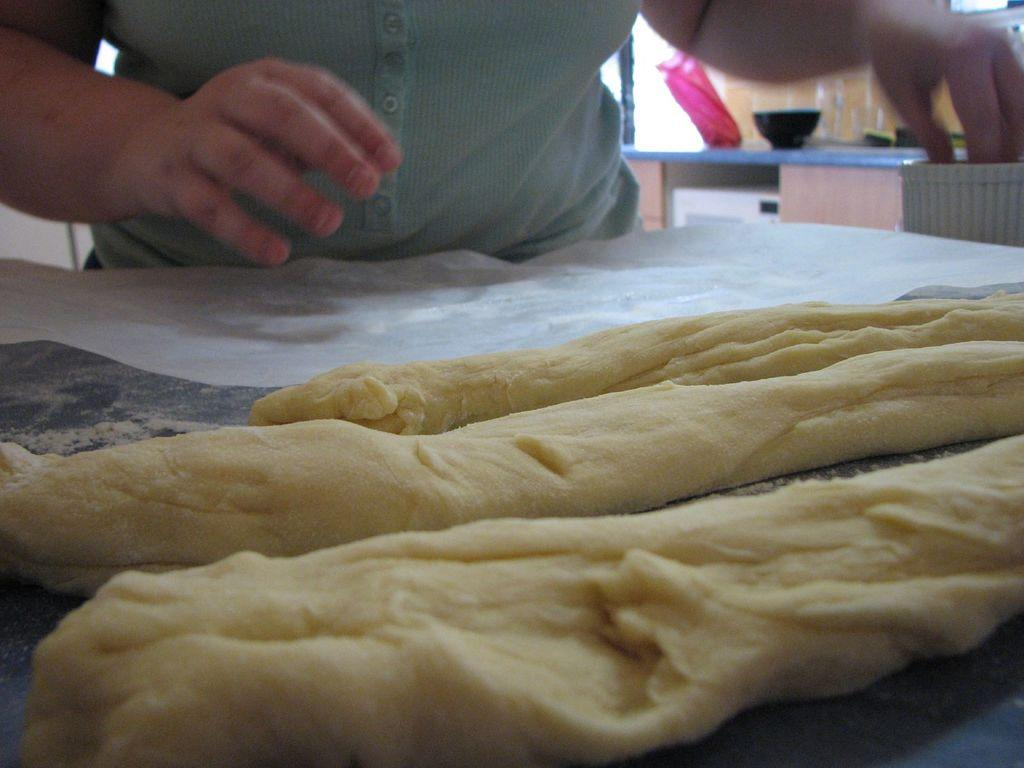What is the main subject on the table in the image? There is a food item on the table in the image. Can you describe the person in the image? There is a person standing behind the table in the image. What else can be seen on the table besides the food item? There are objects placed on the table at the back side. What type of yard is visible in the image? There is no yard visible in the image; it features a table with a food item and a person standing behind it. What can be written in the notebook that is present in the image? There is no notebook present in the image. 